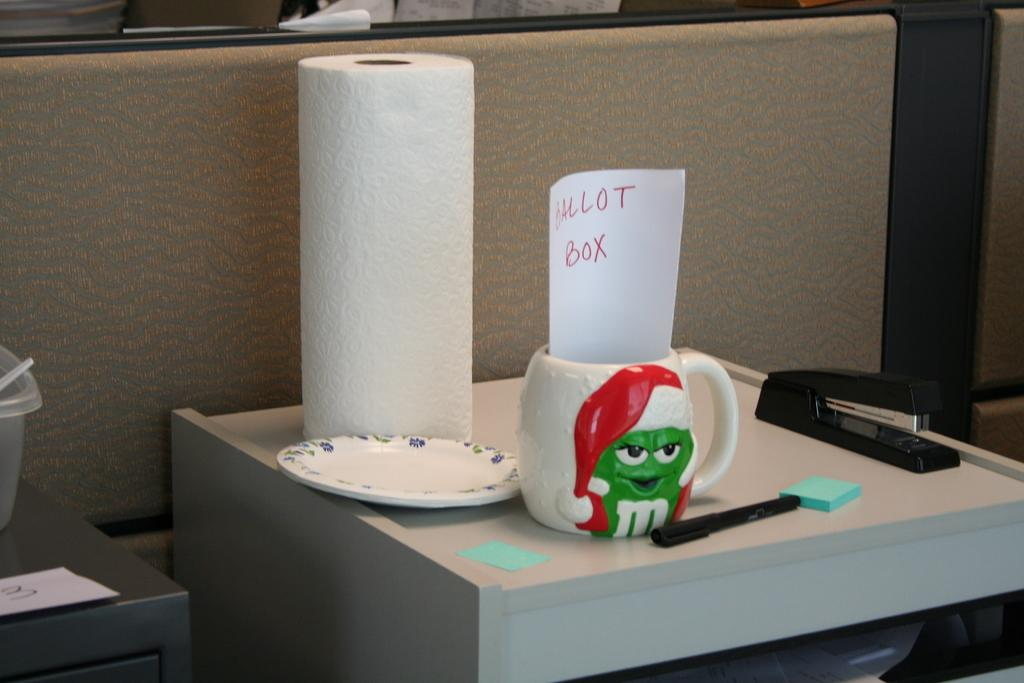What type of stationery item is present in the image? There is a pen in the image. What can be used for holding papers together in the image? There is a stapler in the image for holding papers together. What is a small, flat object in the image? There is a small plate in the image. What can be used for cleaning or wiping in the image? Although not explicitly mentioned, a tissue roll in the image can be used for cleaning or wiping. What is a container for holding liquids in the image? There is a cup in the image for holding liquids. How many rabbits are hopping around the airport in the image? There are no rabbits or airports present in the image. What type of muscle is visible in the image? There are no muscles visible in the image; it contains stationery items and a tissue roll. 